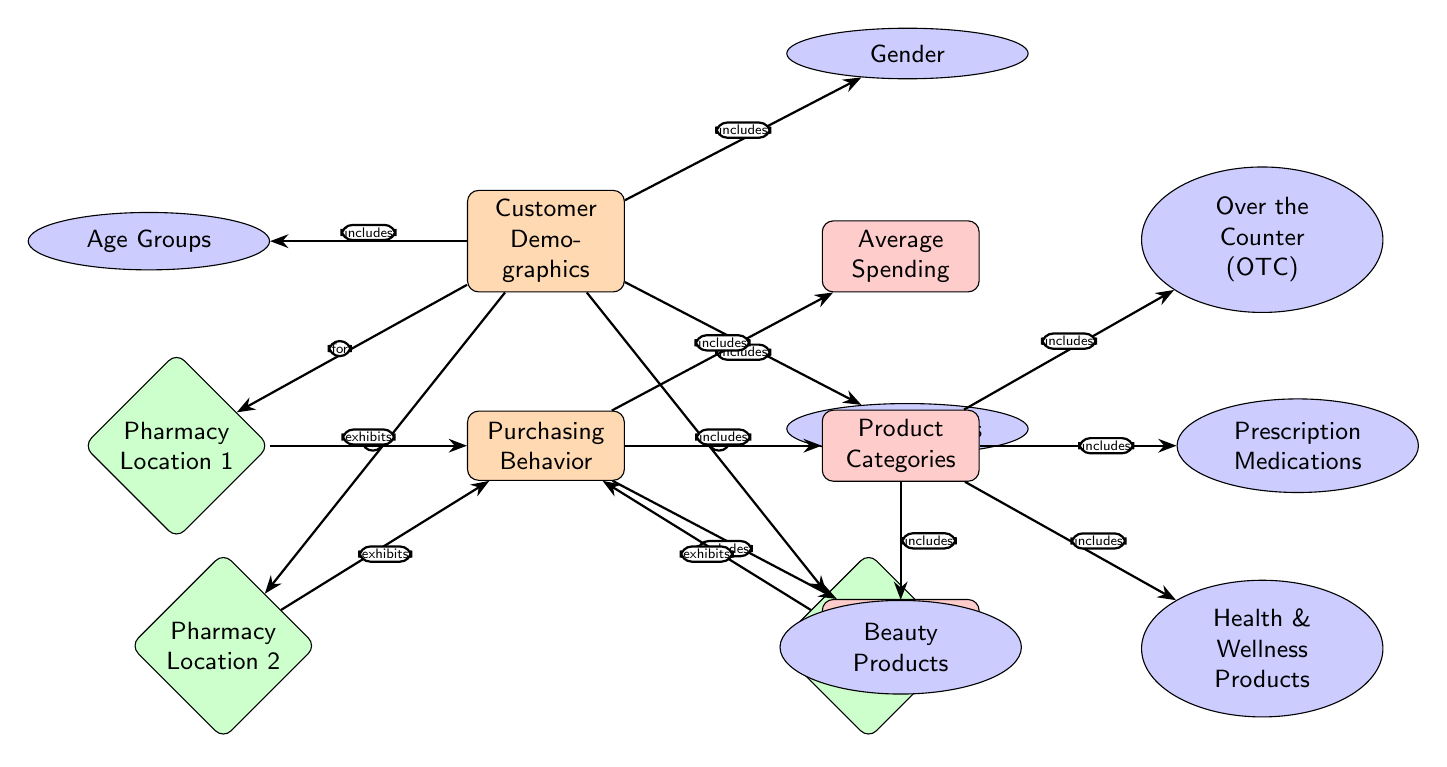What are the customer demographics considered in the diagram? The diagram specifies three customer demographics: Age Groups, Gender, and Income Levels, all branching from the main node labeled Customer Demographics.
Answer: Age Groups, Gender, Income Levels How many pharmacy locations are represented in the diagram? There are three pharmacy locations labeled as Pharmacy Location 1, Pharmacy Location 2, and Pharmacy Location 3, all positioned under the Purchasing Behavior main node.
Answer: 3 What product category is positioned at the bottom right of the diagram? The bottom right node under Product Categories is labeled Health & Wellness Products, making it the specified location within the diagram.
Answer: Health & Wellness Products Which demographic category is included in the connection to Pharmacy Location 1? The connection labeled "for" leads from Customer Demographics to Pharmacy Location 1, meaning the demographic categories Age Groups, Gender, and Income Levels all inform this location. Specifically, age groups are mentioned as influencing customer behavior.
Answer: Age Groups Which purchasing behavior aspect includes seasonal trends? Seasonal Trends is a node directly connected to the Purchasing Behavior node and is categorized under it as one of the aspects influencing customer behavior.
Answer: Seasonal Trends What is the relationship between Purchasing Behavior and Product Categories? The arrow labeled "includes" shows that Purchasing Behavior directly defines or includes various Product Categories such as OTC, Prescription Medications, Health & Wellness Products, and Beauty Products.
Answer: includes What do the arrows from Pharmacy Locations to Purchasing Behavior signify? Each arrow labeled "exhibits" indicates that each pharmacy location (1, 2, and 3) displays particular purchasing behaviors that are influenced by the customer demographics.
Answer: exhibits Which age group is most likely to buy Over the Counter (OTC) products? The diagram does not specify exact demographics for OTC product purchases; however, the relationships imply that customers from relevant Age Groups may influence the purchasing trend of these products.
Answer: Not specified in the diagram Which element is placed above Average Spending in the diagram? The Average Spending node is positioned below and left of the Product Categories node, with the Seasonal Trends node placed below it. This systematic arrangement clarifies their relationships visually in the diagram.
Answer: Product Categories 